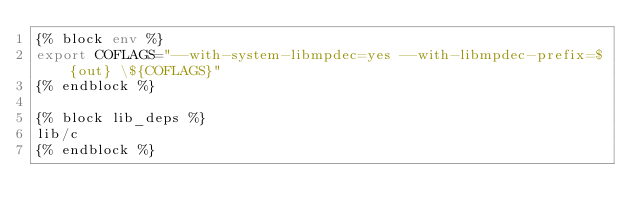<code> <loc_0><loc_0><loc_500><loc_500><_Bash_>{% block env %}
export COFLAGS="--with-system-libmpdec=yes --with-libmpdec-prefix=${out} \${COFLAGS}"
{% endblock %}

{% block lib_deps %}
lib/c
{% endblock %}
</code> 